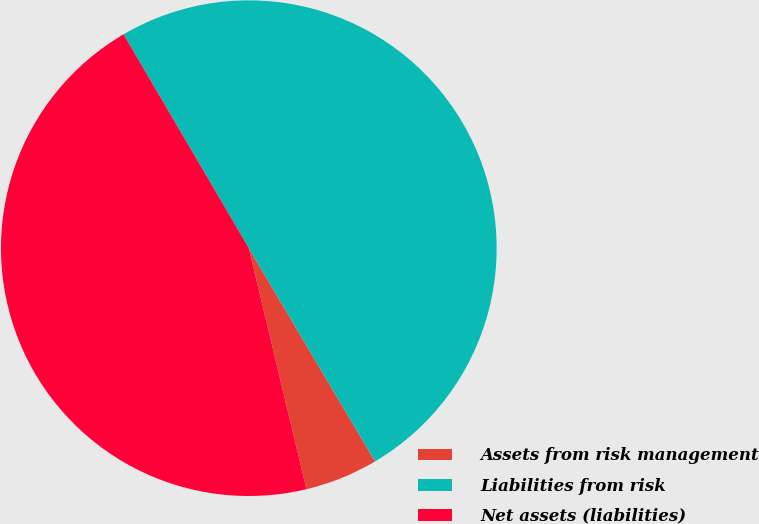Convert chart. <chart><loc_0><loc_0><loc_500><loc_500><pie_chart><fcel>Assets from risk management<fcel>Liabilities from risk<fcel>Net assets (liabilities)<nl><fcel>4.77%<fcel>49.93%<fcel>45.3%<nl></chart> 